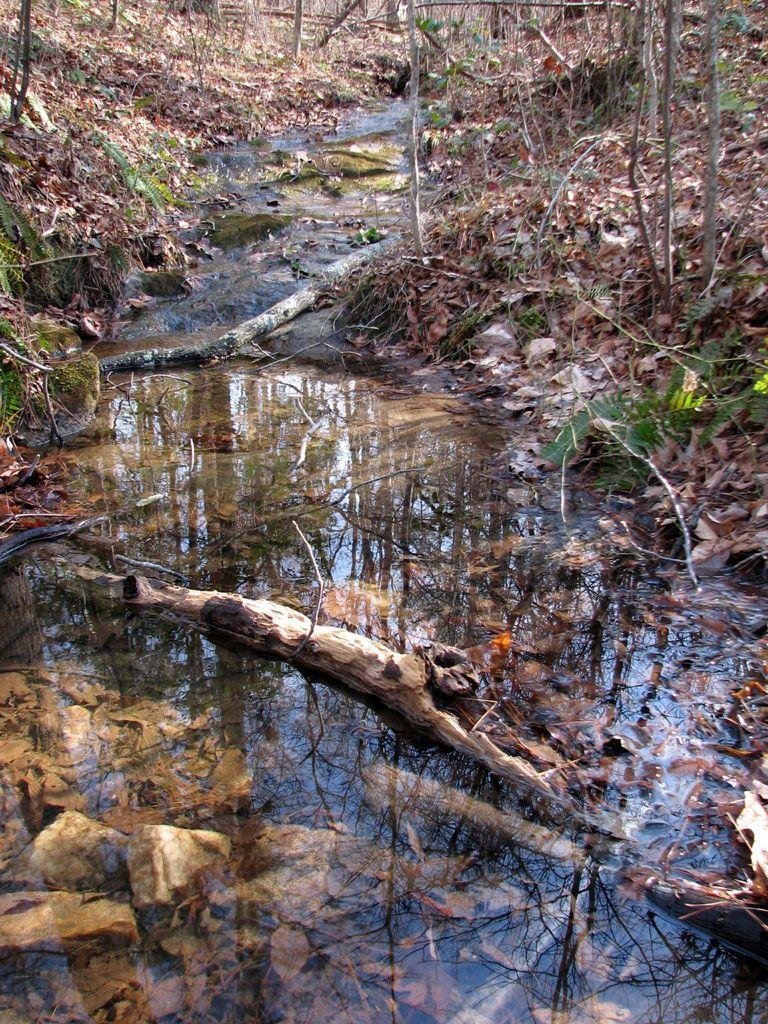What is at the bottom of the image? There is water at the bottom of the image. What objects are in the water? There are wooden sticks in the water. What can be found on the right side of the image? There are dried leaves and twigs on the right side of the image. What is visible in the background of the image? Trees and dried leaves are visible in the background of the image. What type of interest is being earned by the leaves in the image? There is no mention of interest or financial matters in the image; it features natural elements such as water, wooden sticks, and leaves. 